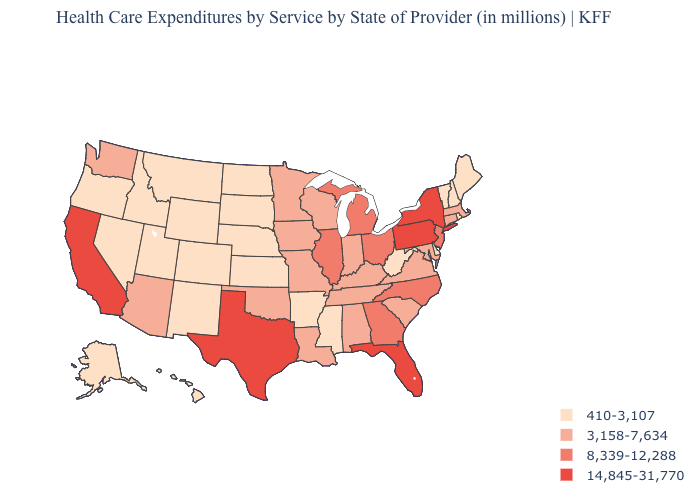Does Ohio have the lowest value in the USA?
Concise answer only. No. What is the value of Mississippi?
Concise answer only. 410-3,107. Which states have the highest value in the USA?
Write a very short answer. California, Florida, New York, Pennsylvania, Texas. Name the states that have a value in the range 410-3,107?
Be succinct. Alaska, Arkansas, Colorado, Delaware, Hawaii, Idaho, Kansas, Maine, Mississippi, Montana, Nebraska, Nevada, New Hampshire, New Mexico, North Dakota, Oregon, Rhode Island, South Dakota, Utah, Vermont, West Virginia, Wyoming. Name the states that have a value in the range 8,339-12,288?
Quick response, please. Georgia, Illinois, Michigan, New Jersey, North Carolina, Ohio. Name the states that have a value in the range 8,339-12,288?
Write a very short answer. Georgia, Illinois, Michigan, New Jersey, North Carolina, Ohio. What is the value of Ohio?
Answer briefly. 8,339-12,288. Does Missouri have the same value as Alabama?
Write a very short answer. Yes. Name the states that have a value in the range 8,339-12,288?
Give a very brief answer. Georgia, Illinois, Michigan, New Jersey, North Carolina, Ohio. Does Virginia have a higher value than Missouri?
Concise answer only. No. What is the highest value in the Northeast ?
Be succinct. 14,845-31,770. What is the value of Michigan?
Give a very brief answer. 8,339-12,288. What is the lowest value in the USA?
Give a very brief answer. 410-3,107. What is the highest value in the USA?
Answer briefly. 14,845-31,770. 